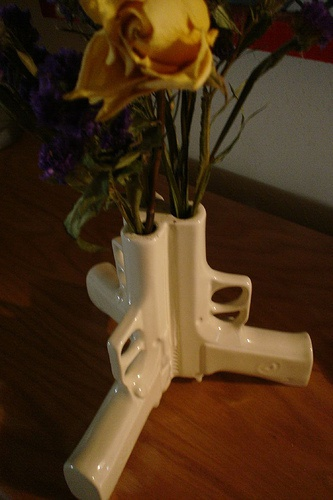Describe the objects in this image and their specific colors. I can see a vase in black, tan, and olive tones in this image. 